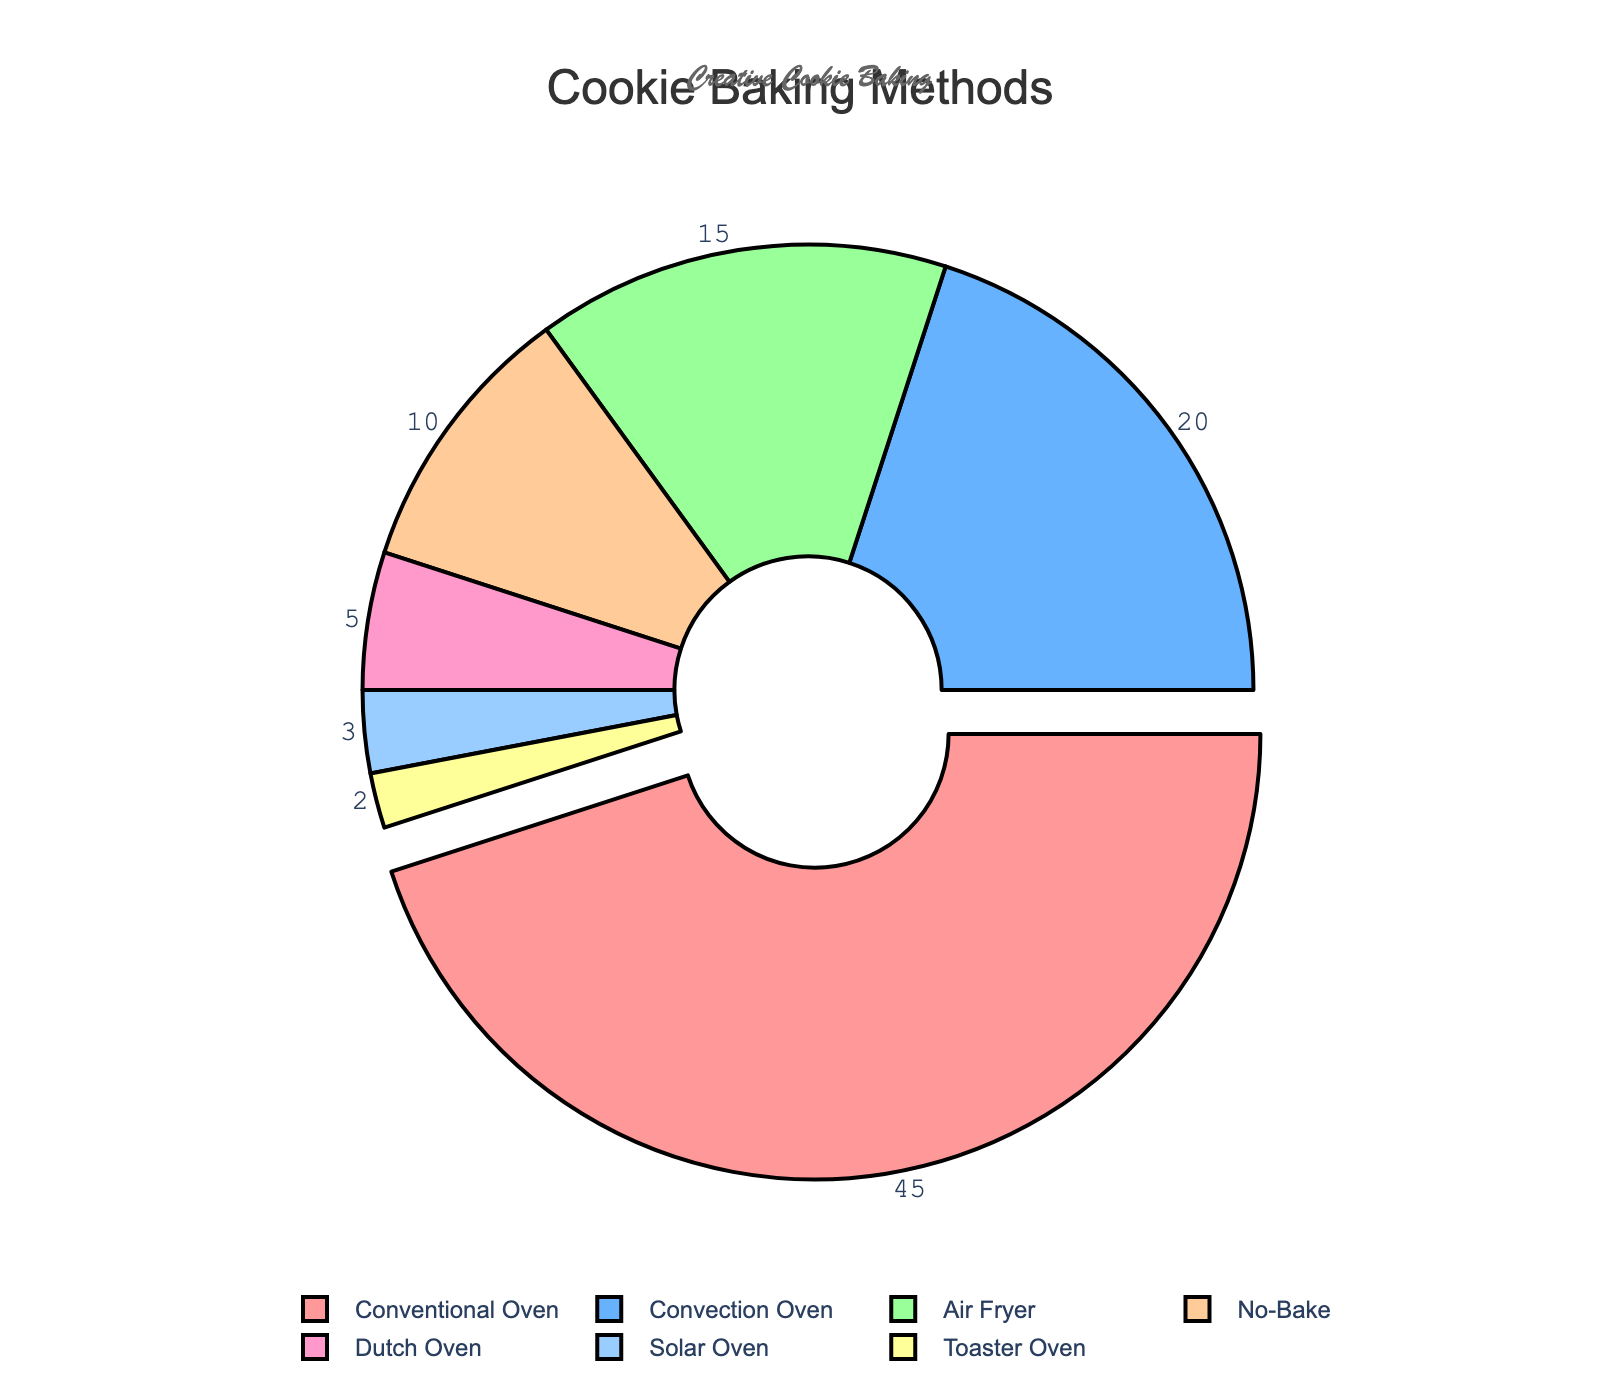Which baking method is used for the fewest percentage of cookie types? According to the pie chart, the smallest segment represents the "Toaster Oven," which is used for 2% of cookie types.
Answer: Toaster Oven Which two baking methods combined cover the majority of cookie types? To determine the combined coverage, add the percentages of the top two methods: "Conventional Oven" (45%) and "Convection Oven" (20%). 45% + 20% = 65%, which is more than half.
Answer: Conventional Oven and Convection Oven How much more popular is the Conventional Oven method compared to the Air Fryer method? Subtract the percentage of the Air Fryer (15%) from that of the Conventional Oven (45%). 45% - 15% = 30%.
Answer: 30% more popular If the No-Bake and Dutch Oven methods are merged into a single category, what would its percentage be in the pie chart? Combine the percentages of No-Bake (10%) and Dutch Oven (5%). 10% + 5% = 15%.
Answer: 15% What percentage of cookie types do the smallest three baking methods account for? Add the percentages for Solar Oven (3%), Toaster Oven (2%), and Dutch Oven (5%). 3% + 2% + 5% = 10%.
Answer: 10% Between the Convection Oven and Air Fryer methods, which one is more popular and by how much? Compare the percentages of the Convection Oven (20%) and the Air Fryer (15%). Subtract the Air Fryer percentage from the Convection Oven percentage: 20% - 15% = 5%.
Answer: Convection Oven by 5% Which baking method corresponds to the orange slice in the pie chart? Identify the color associated with any specific slice if evident in the pie chart. Based on the color coding, compare the orange slice to the legend or notation provided. If orange is mapped to #FFCC99 in the custom color palette, it corresponds to No-Bake which has 10%.
Answer: No-Bake What is the average percentage of the baking methods, excluding the most commonly used method? First, exclude the Conventional Oven percentage (45%). Then average the remaining percentages: (20% + 15% + 10% + 5% + 3% + 2%) / 6. Sum = 55%, Average = 55% / 6 = approximately 9.17%.
Answer: Approximately 9.17% What is the median percentage of all the baking methods? Arrange the percentages in ascending order: 2%, 3%, 5%, 10%, 15%, 20%, 45%. The median is the middle value, which is 10%.
Answer: 10% Which baking methods are represented in shades of blue? Identify the shades of blue in the pie chart and match them with the baking methods. According to the custom color palette, blue shades include #66B2FF and #99CCFF. These represent Convection Oven (20%) and Solar Oven (3%) respectively.
Answer: Convection Oven and Solar Oven 